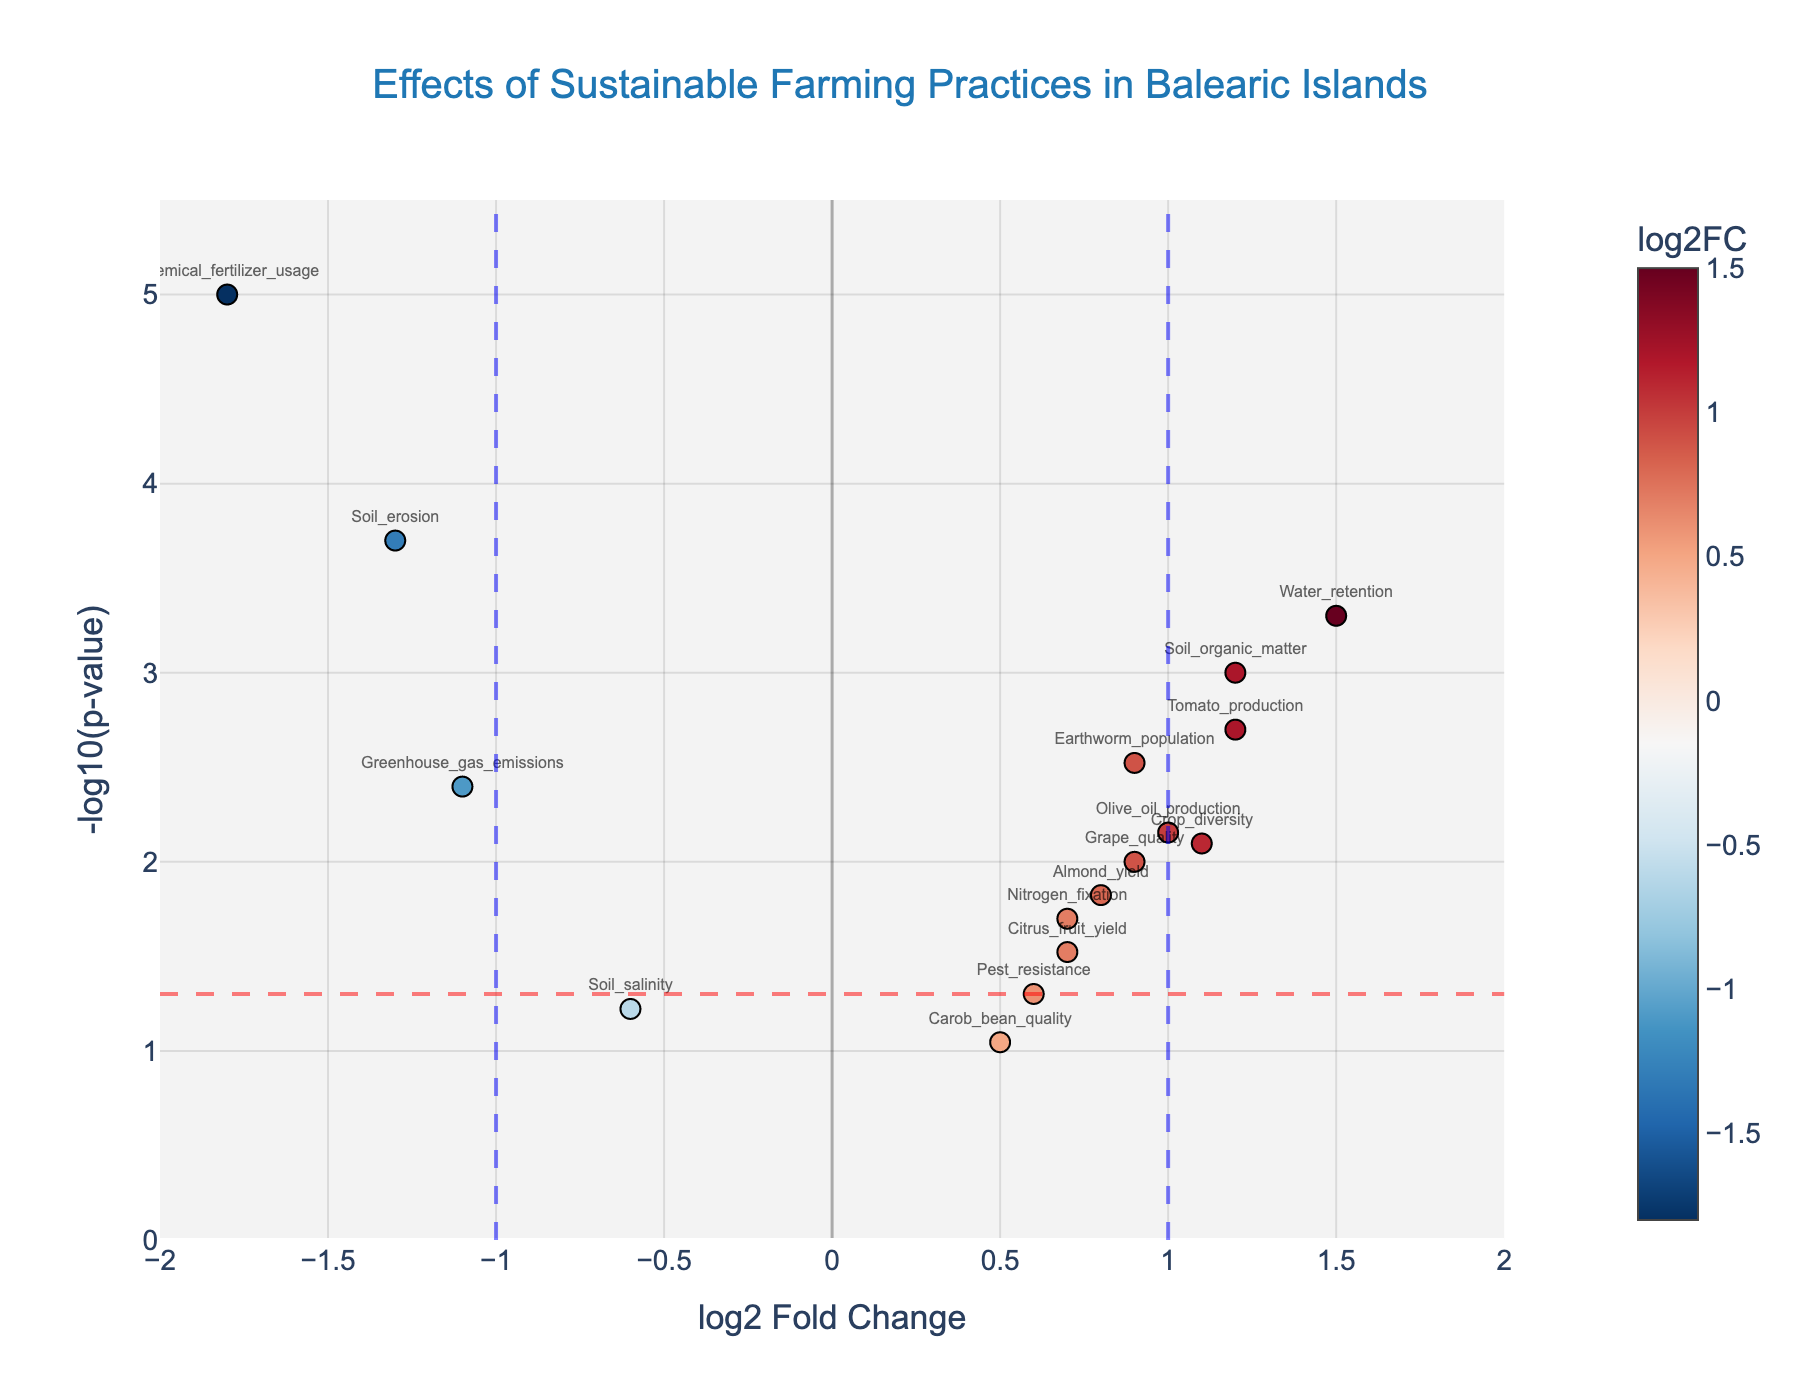What's the title of the figure? The title is usually displayed prominently at the top of the plot. In this case, it is "Effects of Sustainable Farming Practices in Balearic Islands".
Answer: Effects of Sustainable Farming Practices in Balearic Islands How many data points are there in the figure? To determine the number of data points, we need to count the markers on the scatter plot. Each marker corresponds to a gene. There are 16 markers in this figure.
Answer: 16 Which gene has the highest log2 Fold Change? To find the gene with the highest log2 Fold Change, we look for the marker farthest to the right on the x-axis. "Water_retention" has the highest log2 Fold Change of 1.5.
Answer: Water_retention Which data point has the lowest p-value and what is its log2 Fold Change? The data point with the lowest p-value will be the highest on the y-axis since -log10(p-value) is plotted. "Chemical_fertilizer_usage" has the highest y-value, indicating the lowest p-value, and its log2 Fold Change is -1.8.
Answer: Chemical_fertilizer_usage, -1.8 How many genes have a log2 Fold Change greater than or equal to 1? To answer this, count the markers on the right side of the x-axis where log2 Fold Change >= 1. The genes are "Soil_organic_matter", "Water_retention", "Crop_diversity", "Tomato_production". So, there are 4 genes.
Answer: 4 Which genes have a significant p-value below 0.05? We look for genes above the red dashed threshold line, which represents -log10(0.05). The genes are "Soil_organic_matter", "Earthworm_population", "Nitrogen_fixation", "Water_retention", "Crop_diversity", "Soil_erosion", "Chemical_fertilizer_usage", "Almond_yield", "Olive_oil_production", "Grape_quality", and "Greenhouse_gas_emissions".
Answer: 11 genes What's the p-value of "Earthworm_population"? To find the p-value of a specific gene, we check its position and the hover text details. The hover text shows p-value: 0.003 for "Earthworm_population".
Answer: 0.003 What is the relationship between the "Soil_erosion" and "Chemical_fertilizer_usage" in terms of log2 Fold Change and p-value? By comparing their positions on the plot, "Soil_erosion" has a log2 Fold Change of -1.3 and a higher p-value than "Chemical_fertilizer_usage", which has a log2 Fold Change of -1.8 and the lowest p-value. Therefore, "Chemical_fertilizer_usage" has a greater negative effect (lower log2FC) and is more statistically significant (lower p-value).
Answer: Greater negative effect and more statistically significant for "Chemical_fertilizer_usage" Which gene related to crop yield has the highest log2 Fold Change? Crop yield-related genes include "Almond_yield", "Olive_oil_production", "Citrus_fruit_yield", and "Tomato_production". Among these, "Tomato_production" has the highest log2 Fold Change of 1.2.
Answer: Tomato_production Which gene has an increased log2 Fold Change and is significantly less than 1 ppm? Genes with increased log2 Fold Change have positive values on the x-axis. "Almond_yield" has log2 Fold Change of 0.8 with a p-value significantly less than 0.0015 (as it is above the red line).
Answer: Almond_yield 